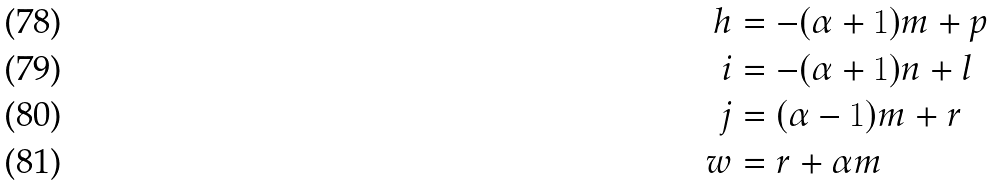<formula> <loc_0><loc_0><loc_500><loc_500>h & = - ( \alpha + 1 ) m + p \\ i & = - ( \alpha + 1 ) n + l \\ j & = ( \alpha - 1 ) m + r \\ w & = r + \alpha m</formula> 